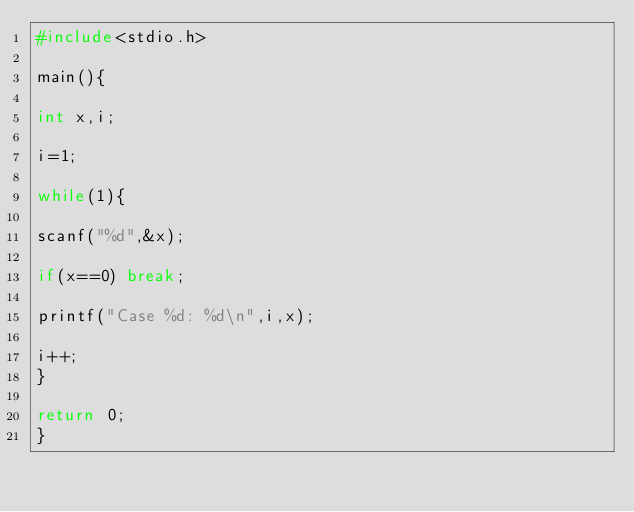Convert code to text. <code><loc_0><loc_0><loc_500><loc_500><_C_>#include<stdio.h>

main(){

int x,i;

i=1;

while(1){

scanf("%d",&x);

if(x==0) break;

printf("Case %d: %d\n",i,x);

i++;
}

return 0;
}</code> 